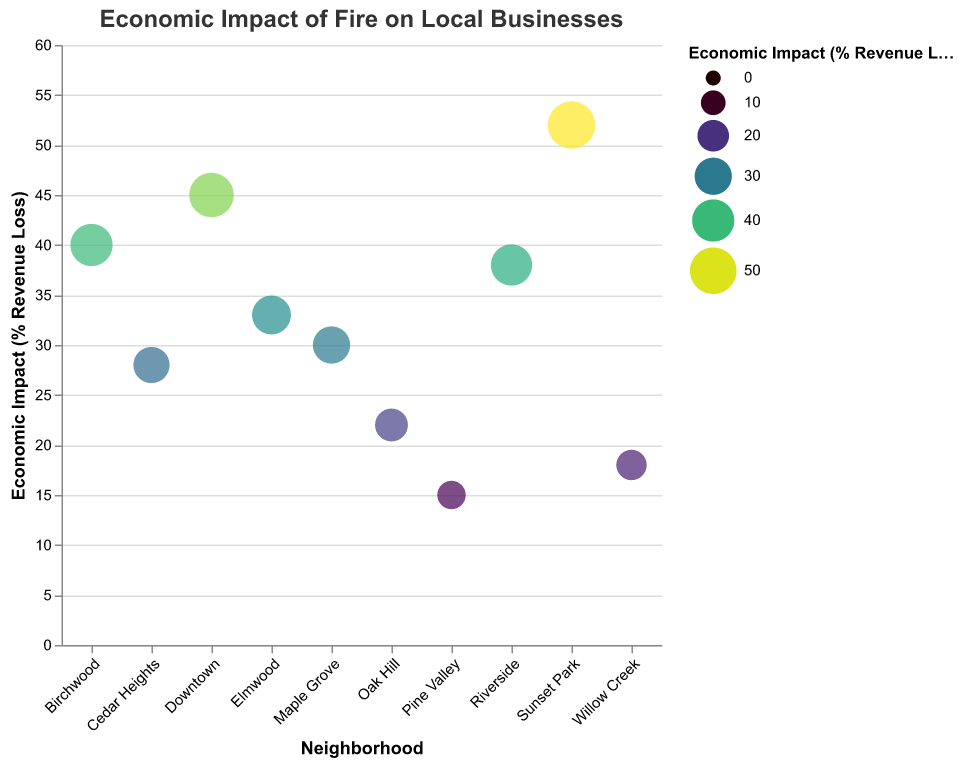What's the economic impact of the fire in Sunset Park? The figure shows the percentage revenue loss for Sunset Park. By examining the relevant data point on the plot, we can see that Sunset Park has an economic impact of 52% revenue loss.
Answer: 52% Which neighborhood has the least economic impact from the fire? To find the neighborhood with the least economic impact, we need to identify the smallest data point on the plot. Pine Valley has the lowest percentage revenue loss at 15%.
Answer: Pine Valley What is the average economic impact of the fire across all neighborhoods? Sum up the revenue losses for all neighborhoods (45 + 38 + 22 + 30 + 15 + 52 + 28 + 18 + 33 + 40 = 321). There are 10 neighborhoods, so the average is 321/10 = 32.1% revenue loss.
Answer: 32.1% Which two neighborhoods have similar economic impacts? Looking at the plot, Downtown (45%) and Birchwood (40%) or Riverside (38%) and Elmwood (33%) have similar percentage revenue losses.
Answer: Downtown and Birchwood or Riverside and Elmwood How many neighborhoods experienced an economic impact greater than 30%? Count the number of data points in the plot that are above the 30% mark. There are 6 neighborhoods: Downtown (45%), Riverside (38%), Sunset Park (52%), Elmwood (33%), Birchwood (40%), and Maple Grove (30%).
Answer: 6 What is the difference in economic impact between Willow Creek and Cedar Heights? Subtract the percentage revenue loss of Willow Creek (18%) from Cedar Heights (28%). This gives 28 - 18 = 10%.
Answer: 10% Which neighborhood experienced the highest economic impact from the fire? Identify the data point with the highest percentage revenue loss in the plot. Sunset Park has the highest impact at 52%.
Answer: Sunset Park What is the combined economic impact on Downtown and Riverside? Sum the revenue losses of Downtown (45%) and Riverside (38%) to find the combined impact. This gives 45 + 38 = 83%.
Answer: 83% How many neighborhoods experienced an economic impact between 30% and 40%? Count the number of data points in the plot within the range of 30% to 40%. There are 3 neighborhoods: Riverside (38%), Elmwood (33%), and Birchwood (40%).
Answer: 3 